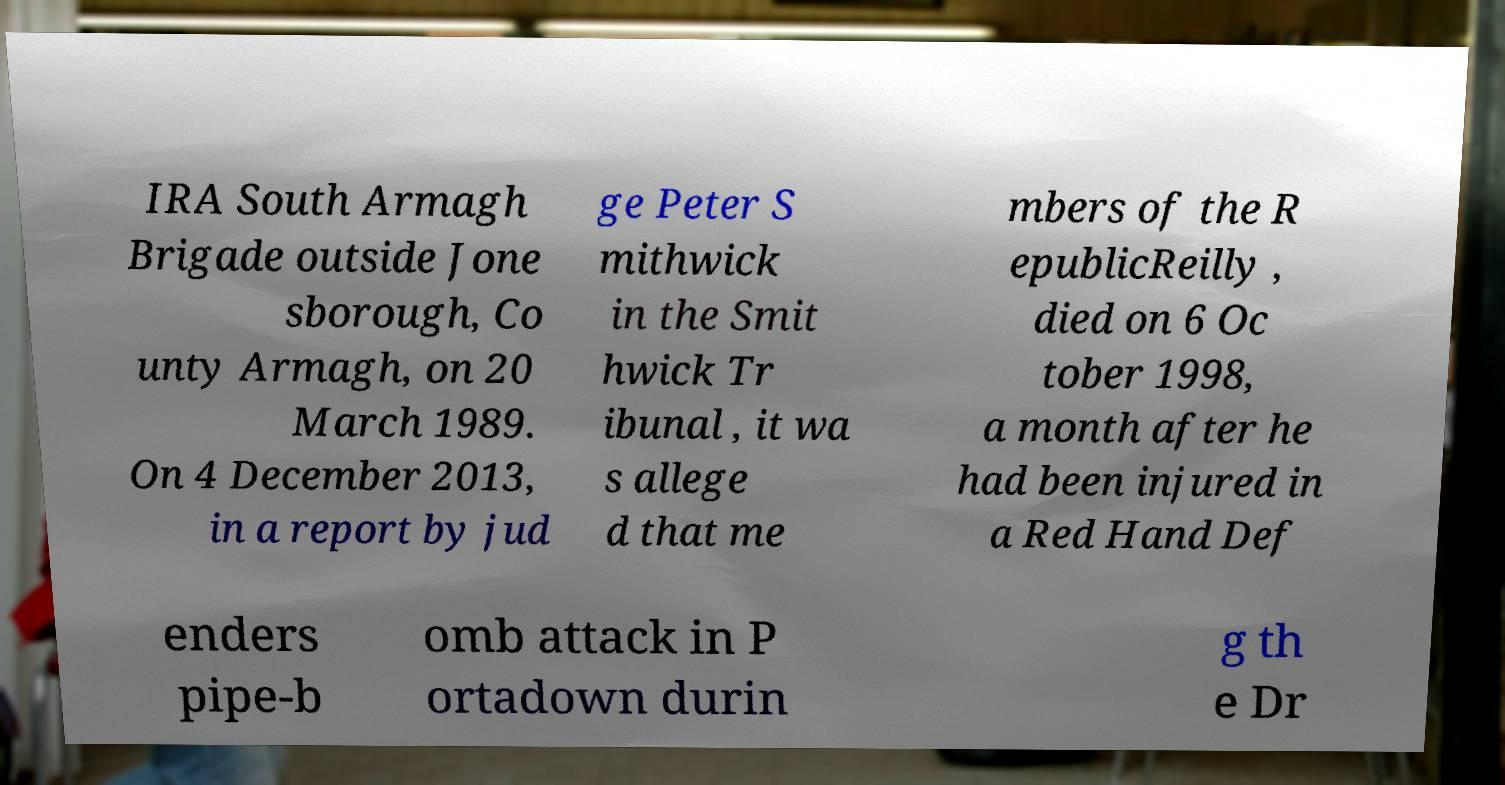Could you extract and type out the text from this image? IRA South Armagh Brigade outside Jone sborough, Co unty Armagh, on 20 March 1989. On 4 December 2013, in a report by jud ge Peter S mithwick in the Smit hwick Tr ibunal , it wa s allege d that me mbers of the R epublicReilly , died on 6 Oc tober 1998, a month after he had been injured in a Red Hand Def enders pipe-b omb attack in P ortadown durin g th e Dr 